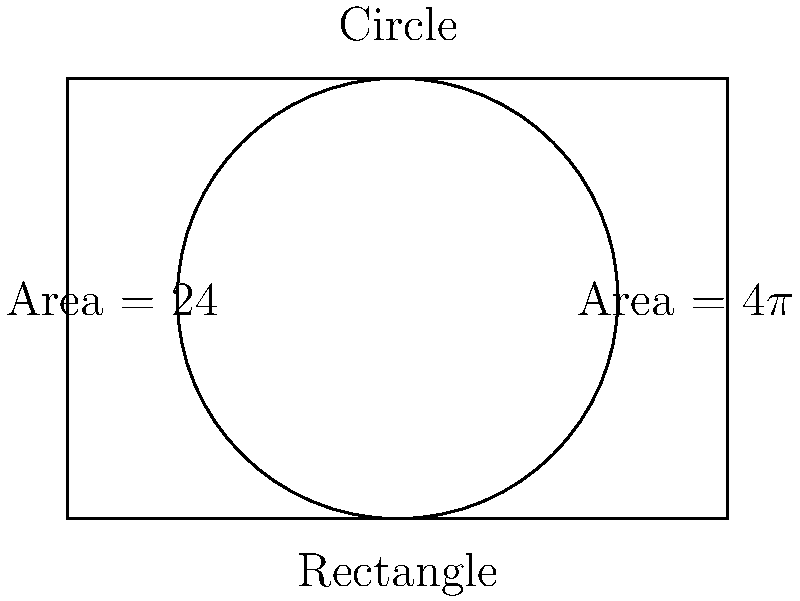As the mayor planning new business districts, you need to design an efficient parking lot. Given a rectangular lot with dimensions 6 units by 4 units and a circular lot with a radius of 2 units, which shape provides more parking space? Assume all space within the shape can be used for parking. To determine which shape provides more parking space, we need to calculate and compare the areas of both shapes:

1. Rectangle:
   Area = length × width
   Area = 6 × 4 = 24 square units

2. Circle:
   Area = $\pi r^2$
   Area = $\pi (2)^2 = 4\pi$ square units

3. Compare the areas:
   Rectangle area: 24 square units
   Circle area: $4\pi \approx 12.57$ square units

4. Calculate the difference:
   24 - $4\pi \approx 11.43$ square units

The rectangular lot provides approximately 11.43 square units more space than the circular lot.

5. Efficiency consideration:
   While the rectangle provides more space, circular designs can sometimes offer better traffic flow. However, for maximizing parking spaces, the rectangular shape is more efficient.
Answer: Rectangular lot (24 sq units vs $4\pi \approx 12.57$ sq units for circular) 